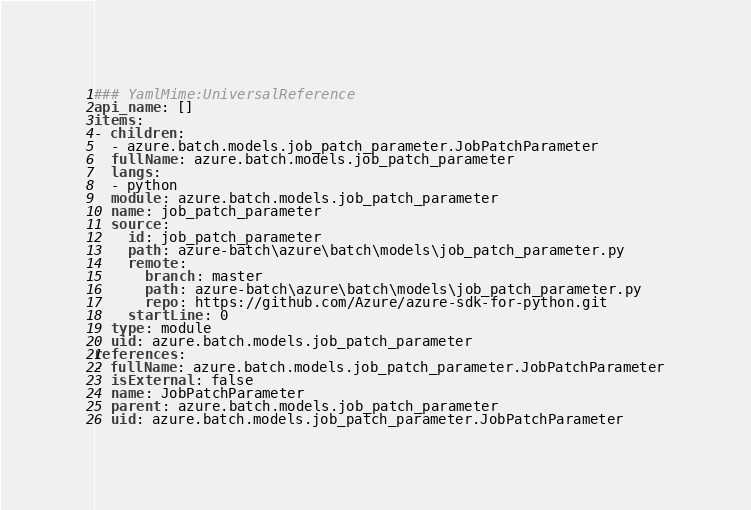<code> <loc_0><loc_0><loc_500><loc_500><_YAML_>### YamlMime:UniversalReference
api_name: []
items:
- children:
  - azure.batch.models.job_patch_parameter.JobPatchParameter
  fullName: azure.batch.models.job_patch_parameter
  langs:
  - python
  module: azure.batch.models.job_patch_parameter
  name: job_patch_parameter
  source:
    id: job_patch_parameter
    path: azure-batch\azure\batch\models\job_patch_parameter.py
    remote:
      branch: master
      path: azure-batch\azure\batch\models\job_patch_parameter.py
      repo: https://github.com/Azure/azure-sdk-for-python.git
    startLine: 0
  type: module
  uid: azure.batch.models.job_patch_parameter
references:
- fullName: azure.batch.models.job_patch_parameter.JobPatchParameter
  isExternal: false
  name: JobPatchParameter
  parent: azure.batch.models.job_patch_parameter
  uid: azure.batch.models.job_patch_parameter.JobPatchParameter
</code> 